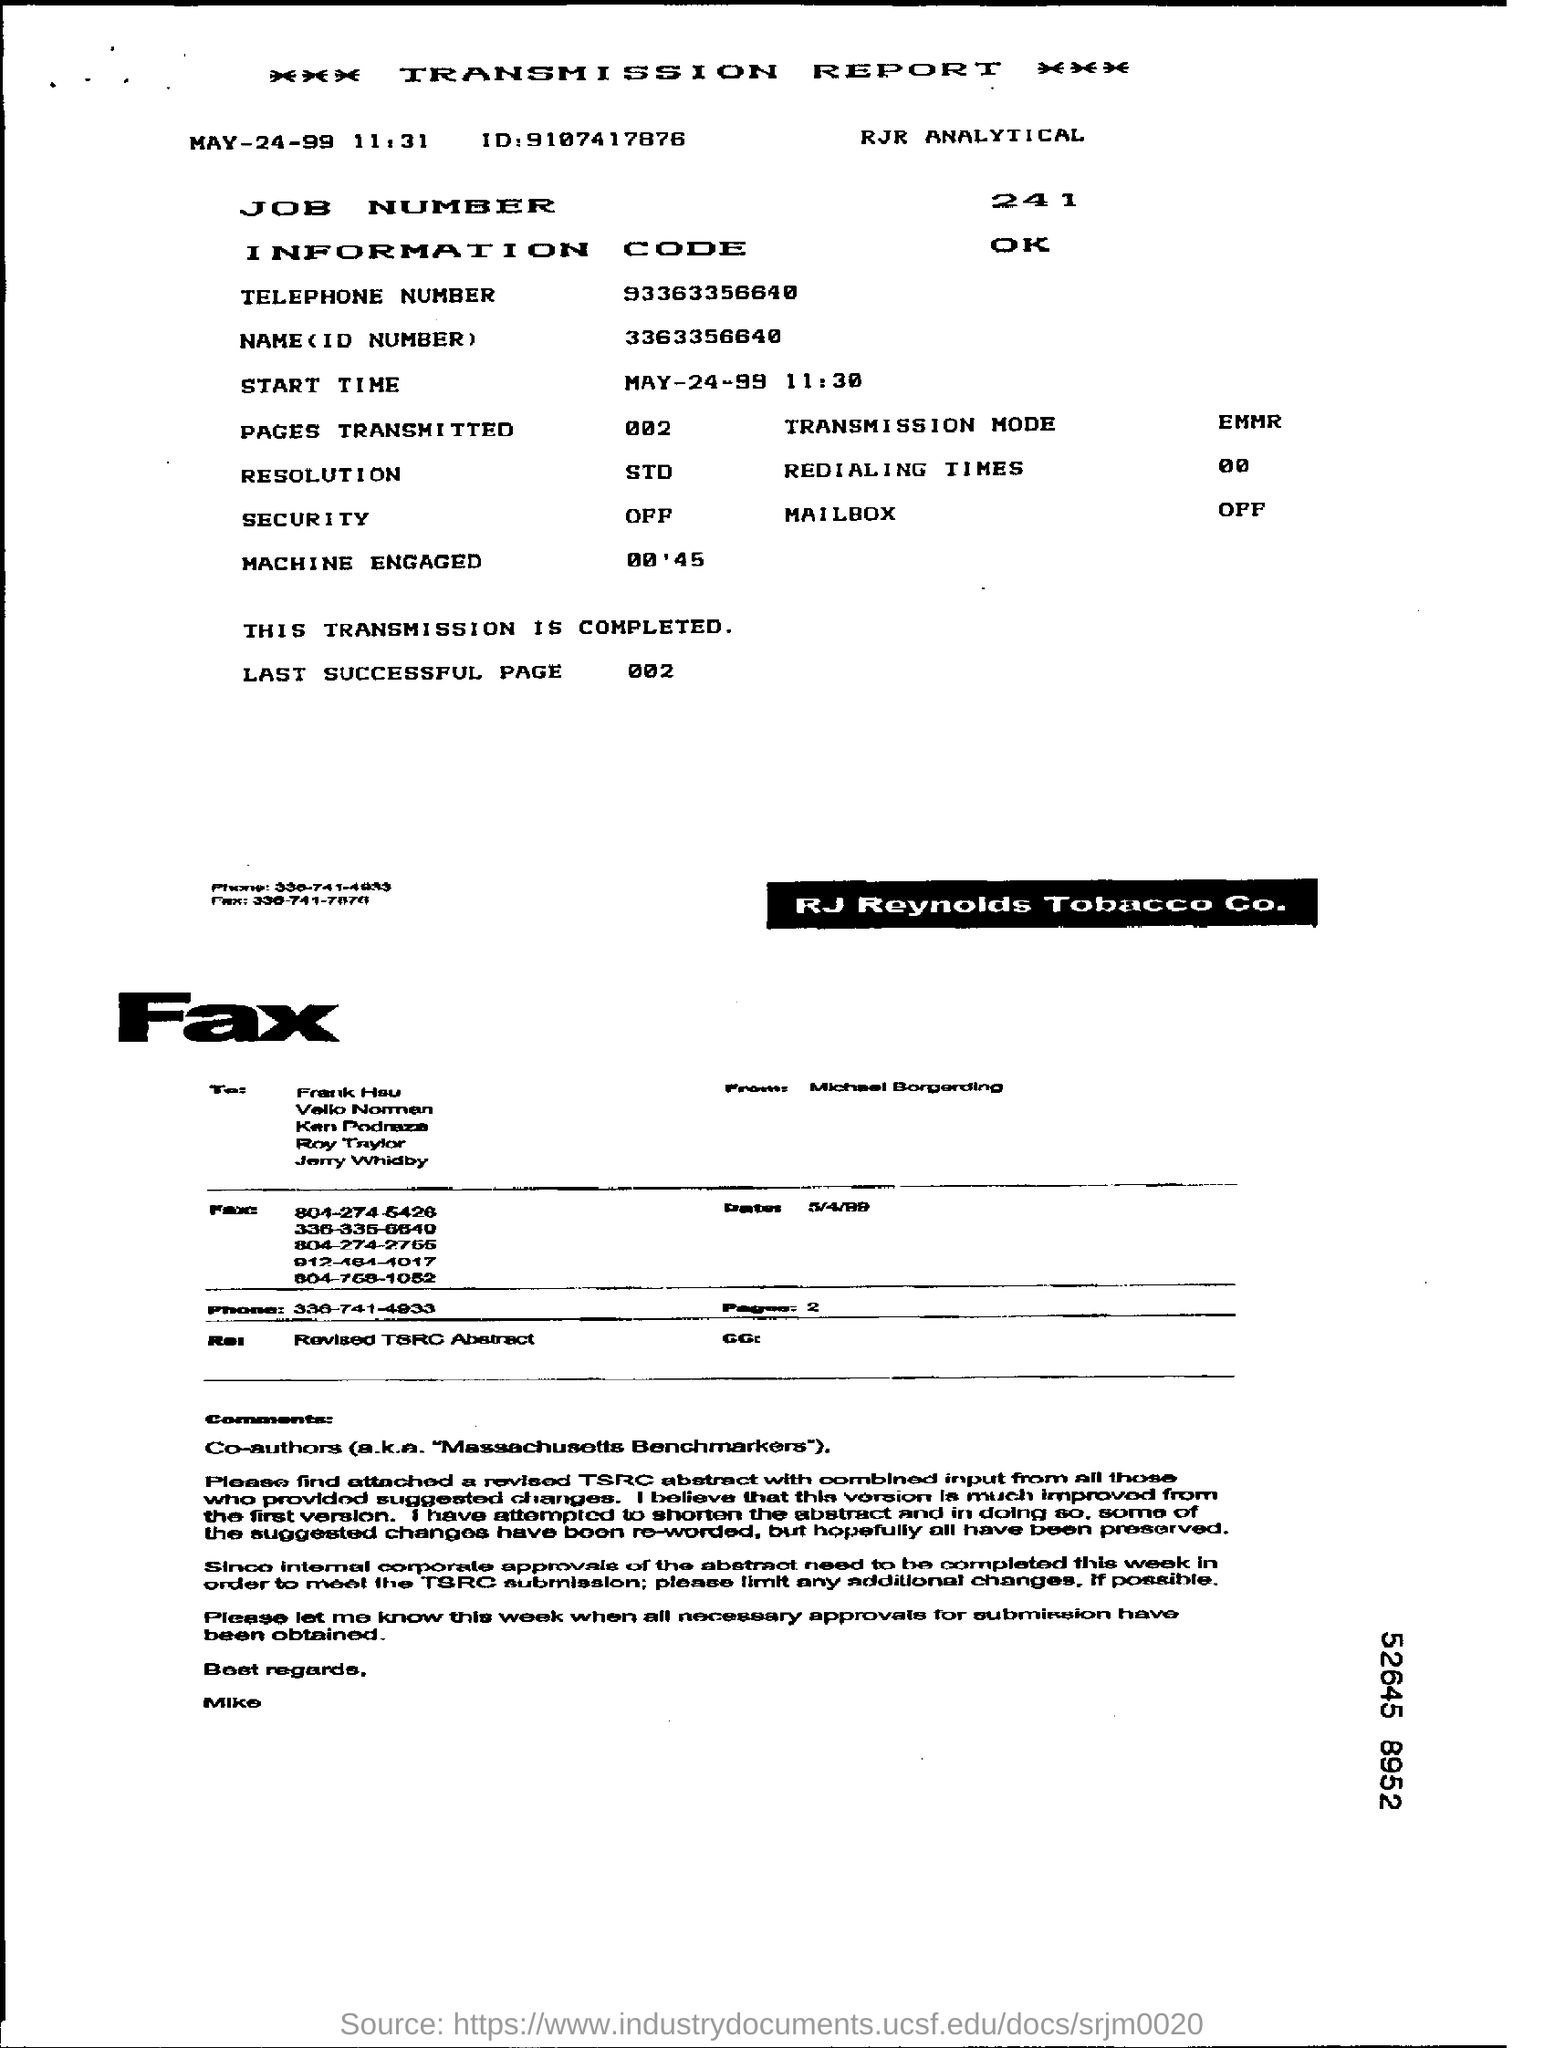Point out several critical features in this image. The START TIME mentioned in the report is 11:30. The last successful page number is 002. 